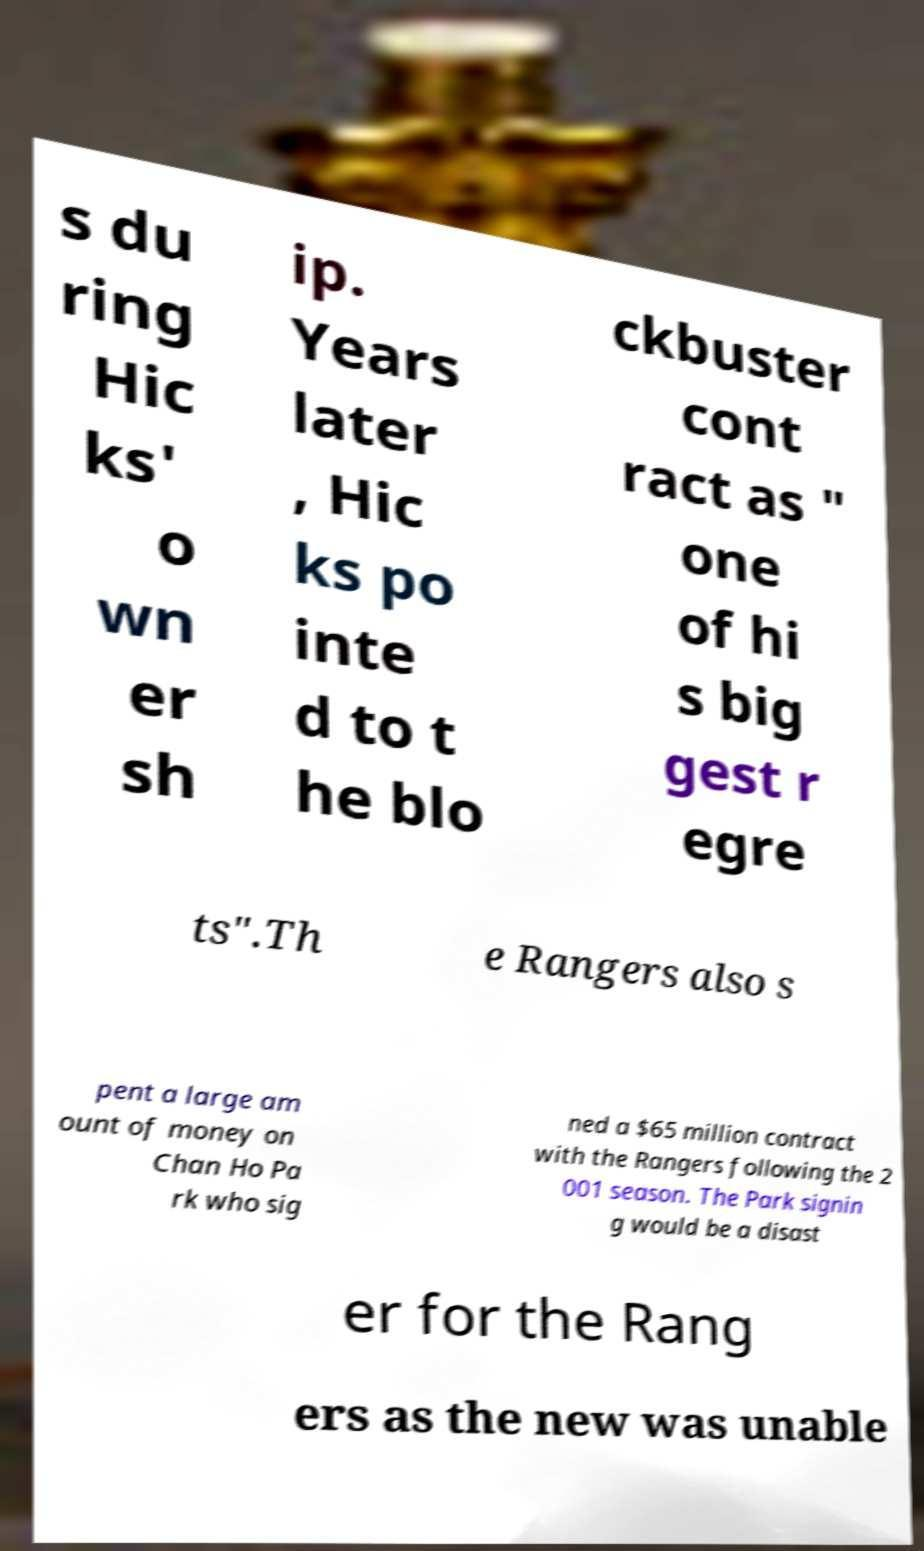Could you assist in decoding the text presented in this image and type it out clearly? s du ring Hic ks' o wn er sh ip. Years later , Hic ks po inte d to t he blo ckbuster cont ract as " one of hi s big gest r egre ts".Th e Rangers also s pent a large am ount of money on Chan Ho Pa rk who sig ned a $65 million contract with the Rangers following the 2 001 season. The Park signin g would be a disast er for the Rang ers as the new was unable 